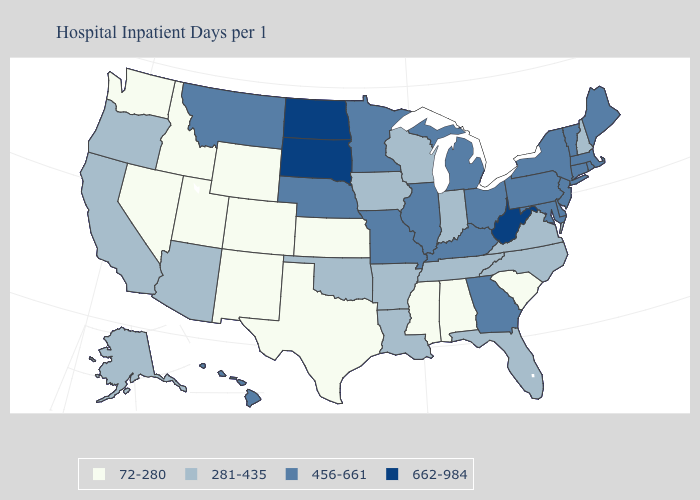Does Alaska have a lower value than Vermont?
Short answer required. Yes. Name the states that have a value in the range 281-435?
Write a very short answer. Alaska, Arizona, Arkansas, California, Florida, Indiana, Iowa, Louisiana, New Hampshire, North Carolina, Oklahoma, Oregon, Tennessee, Virginia, Wisconsin. What is the lowest value in the MidWest?
Quick response, please. 72-280. Among the states that border Kentucky , which have the highest value?
Keep it brief. West Virginia. Is the legend a continuous bar?
Quick response, please. No. Name the states that have a value in the range 662-984?
Keep it brief. North Dakota, South Dakota, West Virginia. What is the value of Alabama?
Answer briefly. 72-280. Does Mississippi have a lower value than Washington?
Give a very brief answer. No. Which states have the highest value in the USA?
Give a very brief answer. North Dakota, South Dakota, West Virginia. Does Florida have a lower value than Oregon?
Answer briefly. No. Does Massachusetts have the same value as South Dakota?
Be succinct. No. What is the highest value in the USA?
Concise answer only. 662-984. What is the value of Georgia?
Write a very short answer. 456-661. How many symbols are there in the legend?
Quick response, please. 4. 